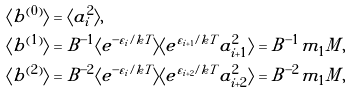<formula> <loc_0><loc_0><loc_500><loc_500>\langle b ^ { ( 0 ) } \rangle & = \langle a _ { i } ^ { 2 } \rangle , \\ \langle b ^ { ( 1 ) } \rangle & = B ^ { - 1 } \langle e ^ { - \varepsilon _ { i } / k T } \rangle \langle e ^ { \varepsilon _ { i + 1 } / k T } a _ { i + 1 } ^ { 2 } \rangle = B ^ { - 1 } m _ { 1 } M , \\ \langle b ^ { ( 2 ) } \rangle & = B ^ { - 2 } \langle e ^ { - \varepsilon _ { i } / k T } \rangle \langle e ^ { \varepsilon _ { i + 2 } / k T } a _ { i + 2 } ^ { 2 } \rangle = B ^ { - 2 } m _ { 1 } M , \\</formula> 